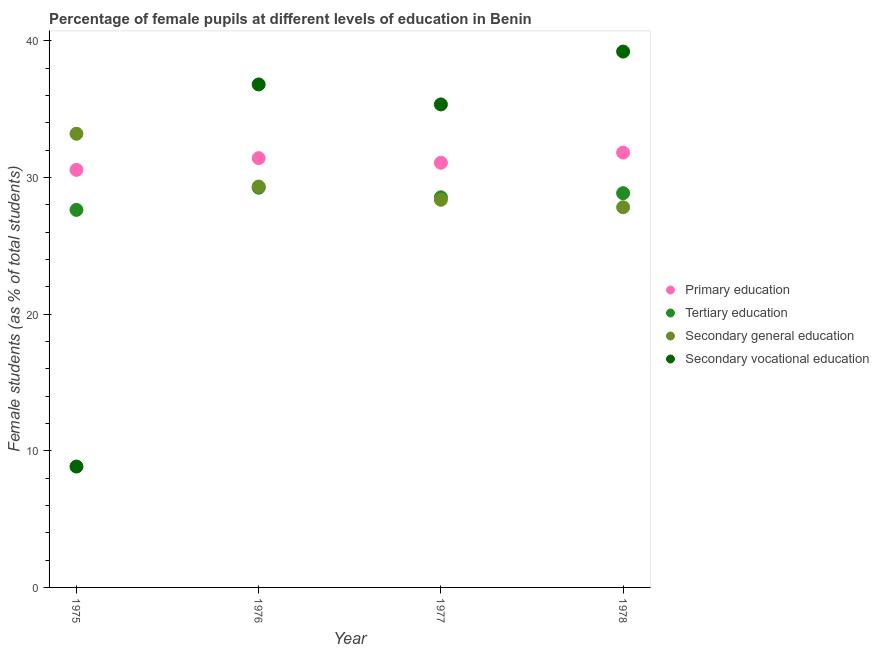Is the number of dotlines equal to the number of legend labels?
Offer a terse response. Yes. What is the percentage of female students in tertiary education in 1975?
Your answer should be very brief. 27.62. Across all years, what is the maximum percentage of female students in tertiary education?
Your answer should be very brief. 29.25. Across all years, what is the minimum percentage of female students in primary education?
Your answer should be compact. 30.55. In which year was the percentage of female students in tertiary education maximum?
Offer a very short reply. 1976. In which year was the percentage of female students in primary education minimum?
Offer a terse response. 1975. What is the total percentage of female students in tertiary education in the graph?
Give a very brief answer. 114.26. What is the difference between the percentage of female students in secondary education in 1975 and that in 1977?
Your answer should be compact. 4.83. What is the difference between the percentage of female students in secondary vocational education in 1975 and the percentage of female students in primary education in 1978?
Provide a short and direct response. -22.97. What is the average percentage of female students in secondary education per year?
Give a very brief answer. 29.68. In the year 1975, what is the difference between the percentage of female students in secondary vocational education and percentage of female students in primary education?
Your response must be concise. -21.71. In how many years, is the percentage of female students in secondary vocational education greater than 6 %?
Your answer should be compact. 4. What is the ratio of the percentage of female students in primary education in 1975 to that in 1978?
Make the answer very short. 0.96. Is the difference between the percentage of female students in secondary vocational education in 1975 and 1976 greater than the difference between the percentage of female students in primary education in 1975 and 1976?
Keep it short and to the point. No. What is the difference between the highest and the second highest percentage of female students in tertiary education?
Your answer should be compact. 0.4. What is the difference between the highest and the lowest percentage of female students in secondary education?
Your response must be concise. 5.38. Is the sum of the percentage of female students in secondary education in 1975 and 1976 greater than the maximum percentage of female students in secondary vocational education across all years?
Offer a very short reply. Yes. Does the percentage of female students in tertiary education monotonically increase over the years?
Your response must be concise. No. Is the percentage of female students in secondary education strictly less than the percentage of female students in primary education over the years?
Make the answer very short. No. How many dotlines are there?
Make the answer very short. 4. Does the graph contain grids?
Your answer should be compact. No. Where does the legend appear in the graph?
Your answer should be very brief. Center right. What is the title of the graph?
Offer a very short reply. Percentage of female pupils at different levels of education in Benin. Does "Social equity" appear as one of the legend labels in the graph?
Your answer should be very brief. No. What is the label or title of the Y-axis?
Ensure brevity in your answer.  Female students (as % of total students). What is the Female students (as % of total students) in Primary education in 1975?
Make the answer very short. 30.55. What is the Female students (as % of total students) in Tertiary education in 1975?
Your answer should be very brief. 27.62. What is the Female students (as % of total students) of Secondary general education in 1975?
Your answer should be very brief. 33.19. What is the Female students (as % of total students) in Secondary vocational education in 1975?
Offer a very short reply. 8.84. What is the Female students (as % of total students) in Primary education in 1976?
Provide a succinct answer. 31.41. What is the Female students (as % of total students) in Tertiary education in 1976?
Your answer should be compact. 29.25. What is the Female students (as % of total students) of Secondary general education in 1976?
Keep it short and to the point. 29.33. What is the Female students (as % of total students) of Secondary vocational education in 1976?
Provide a succinct answer. 36.8. What is the Female students (as % of total students) of Primary education in 1977?
Make the answer very short. 31.07. What is the Female students (as % of total students) of Tertiary education in 1977?
Give a very brief answer. 28.54. What is the Female students (as % of total students) of Secondary general education in 1977?
Keep it short and to the point. 28.36. What is the Female students (as % of total students) in Secondary vocational education in 1977?
Your answer should be very brief. 35.34. What is the Female students (as % of total students) in Primary education in 1978?
Your answer should be very brief. 31.81. What is the Female students (as % of total students) in Tertiary education in 1978?
Keep it short and to the point. 28.84. What is the Female students (as % of total students) in Secondary general education in 1978?
Provide a short and direct response. 27.81. What is the Female students (as % of total students) of Secondary vocational education in 1978?
Provide a succinct answer. 39.21. Across all years, what is the maximum Female students (as % of total students) of Primary education?
Keep it short and to the point. 31.81. Across all years, what is the maximum Female students (as % of total students) of Tertiary education?
Your answer should be very brief. 29.25. Across all years, what is the maximum Female students (as % of total students) of Secondary general education?
Offer a terse response. 33.19. Across all years, what is the maximum Female students (as % of total students) of Secondary vocational education?
Keep it short and to the point. 39.21. Across all years, what is the minimum Female students (as % of total students) in Primary education?
Keep it short and to the point. 30.55. Across all years, what is the minimum Female students (as % of total students) of Tertiary education?
Keep it short and to the point. 27.62. Across all years, what is the minimum Female students (as % of total students) in Secondary general education?
Ensure brevity in your answer.  27.81. Across all years, what is the minimum Female students (as % of total students) in Secondary vocational education?
Offer a very short reply. 8.84. What is the total Female students (as % of total students) of Primary education in the graph?
Offer a very short reply. 124.85. What is the total Female students (as % of total students) of Tertiary education in the graph?
Provide a short and direct response. 114.26. What is the total Female students (as % of total students) of Secondary general education in the graph?
Your answer should be very brief. 118.7. What is the total Female students (as % of total students) in Secondary vocational education in the graph?
Keep it short and to the point. 120.19. What is the difference between the Female students (as % of total students) in Primary education in 1975 and that in 1976?
Your response must be concise. -0.86. What is the difference between the Female students (as % of total students) in Tertiary education in 1975 and that in 1976?
Your answer should be compact. -1.62. What is the difference between the Female students (as % of total students) of Secondary general education in 1975 and that in 1976?
Your response must be concise. 3.86. What is the difference between the Female students (as % of total students) in Secondary vocational education in 1975 and that in 1976?
Offer a terse response. -27.96. What is the difference between the Female students (as % of total students) in Primary education in 1975 and that in 1977?
Make the answer very short. -0.52. What is the difference between the Female students (as % of total students) in Tertiary education in 1975 and that in 1977?
Offer a very short reply. -0.92. What is the difference between the Female students (as % of total students) of Secondary general education in 1975 and that in 1977?
Your answer should be very brief. 4.83. What is the difference between the Female students (as % of total students) of Secondary vocational education in 1975 and that in 1977?
Keep it short and to the point. -26.5. What is the difference between the Female students (as % of total students) of Primary education in 1975 and that in 1978?
Offer a very short reply. -1.26. What is the difference between the Female students (as % of total students) of Tertiary education in 1975 and that in 1978?
Offer a very short reply. -1.22. What is the difference between the Female students (as % of total students) in Secondary general education in 1975 and that in 1978?
Provide a succinct answer. 5.38. What is the difference between the Female students (as % of total students) of Secondary vocational education in 1975 and that in 1978?
Provide a short and direct response. -30.36. What is the difference between the Female students (as % of total students) of Primary education in 1976 and that in 1977?
Provide a succinct answer. 0.34. What is the difference between the Female students (as % of total students) of Tertiary education in 1976 and that in 1977?
Your response must be concise. 0.7. What is the difference between the Female students (as % of total students) of Secondary general education in 1976 and that in 1977?
Provide a short and direct response. 0.97. What is the difference between the Female students (as % of total students) in Secondary vocational education in 1976 and that in 1977?
Offer a very short reply. 1.46. What is the difference between the Female students (as % of total students) of Primary education in 1976 and that in 1978?
Keep it short and to the point. -0.41. What is the difference between the Female students (as % of total students) in Tertiary education in 1976 and that in 1978?
Provide a succinct answer. 0.4. What is the difference between the Female students (as % of total students) of Secondary general education in 1976 and that in 1978?
Ensure brevity in your answer.  1.52. What is the difference between the Female students (as % of total students) of Secondary vocational education in 1976 and that in 1978?
Ensure brevity in your answer.  -2.4. What is the difference between the Female students (as % of total students) of Primary education in 1977 and that in 1978?
Make the answer very short. -0.74. What is the difference between the Female students (as % of total students) of Tertiary education in 1977 and that in 1978?
Offer a terse response. -0.3. What is the difference between the Female students (as % of total students) in Secondary general education in 1977 and that in 1978?
Make the answer very short. 0.55. What is the difference between the Female students (as % of total students) in Secondary vocational education in 1977 and that in 1978?
Your response must be concise. -3.87. What is the difference between the Female students (as % of total students) in Primary education in 1975 and the Female students (as % of total students) in Tertiary education in 1976?
Offer a terse response. 1.31. What is the difference between the Female students (as % of total students) of Primary education in 1975 and the Female students (as % of total students) of Secondary general education in 1976?
Provide a succinct answer. 1.22. What is the difference between the Female students (as % of total students) in Primary education in 1975 and the Female students (as % of total students) in Secondary vocational education in 1976?
Ensure brevity in your answer.  -6.25. What is the difference between the Female students (as % of total students) of Tertiary education in 1975 and the Female students (as % of total students) of Secondary general education in 1976?
Offer a very short reply. -1.71. What is the difference between the Female students (as % of total students) of Tertiary education in 1975 and the Female students (as % of total students) of Secondary vocational education in 1976?
Offer a very short reply. -9.18. What is the difference between the Female students (as % of total students) in Secondary general education in 1975 and the Female students (as % of total students) in Secondary vocational education in 1976?
Make the answer very short. -3.61. What is the difference between the Female students (as % of total students) of Primary education in 1975 and the Female students (as % of total students) of Tertiary education in 1977?
Offer a very short reply. 2.01. What is the difference between the Female students (as % of total students) of Primary education in 1975 and the Female students (as % of total students) of Secondary general education in 1977?
Give a very brief answer. 2.19. What is the difference between the Female students (as % of total students) of Primary education in 1975 and the Female students (as % of total students) of Secondary vocational education in 1977?
Offer a very short reply. -4.79. What is the difference between the Female students (as % of total students) of Tertiary education in 1975 and the Female students (as % of total students) of Secondary general education in 1977?
Ensure brevity in your answer.  -0.74. What is the difference between the Female students (as % of total students) of Tertiary education in 1975 and the Female students (as % of total students) of Secondary vocational education in 1977?
Keep it short and to the point. -7.72. What is the difference between the Female students (as % of total students) of Secondary general education in 1975 and the Female students (as % of total students) of Secondary vocational education in 1977?
Your answer should be compact. -2.15. What is the difference between the Female students (as % of total students) in Primary education in 1975 and the Female students (as % of total students) in Tertiary education in 1978?
Provide a short and direct response. 1.71. What is the difference between the Female students (as % of total students) in Primary education in 1975 and the Female students (as % of total students) in Secondary general education in 1978?
Offer a very short reply. 2.74. What is the difference between the Female students (as % of total students) of Primary education in 1975 and the Female students (as % of total students) of Secondary vocational education in 1978?
Your answer should be compact. -8.65. What is the difference between the Female students (as % of total students) of Tertiary education in 1975 and the Female students (as % of total students) of Secondary general education in 1978?
Keep it short and to the point. -0.19. What is the difference between the Female students (as % of total students) in Tertiary education in 1975 and the Female students (as % of total students) in Secondary vocational education in 1978?
Your answer should be compact. -11.58. What is the difference between the Female students (as % of total students) of Secondary general education in 1975 and the Female students (as % of total students) of Secondary vocational education in 1978?
Provide a succinct answer. -6.01. What is the difference between the Female students (as % of total students) in Primary education in 1976 and the Female students (as % of total students) in Tertiary education in 1977?
Ensure brevity in your answer.  2.87. What is the difference between the Female students (as % of total students) in Primary education in 1976 and the Female students (as % of total students) in Secondary general education in 1977?
Provide a short and direct response. 3.04. What is the difference between the Female students (as % of total students) in Primary education in 1976 and the Female students (as % of total students) in Secondary vocational education in 1977?
Your response must be concise. -3.93. What is the difference between the Female students (as % of total students) of Tertiary education in 1976 and the Female students (as % of total students) of Secondary general education in 1977?
Your answer should be very brief. 0.88. What is the difference between the Female students (as % of total students) of Tertiary education in 1976 and the Female students (as % of total students) of Secondary vocational education in 1977?
Offer a very short reply. -6.09. What is the difference between the Female students (as % of total students) of Secondary general education in 1976 and the Female students (as % of total students) of Secondary vocational education in 1977?
Give a very brief answer. -6.01. What is the difference between the Female students (as % of total students) of Primary education in 1976 and the Female students (as % of total students) of Tertiary education in 1978?
Offer a very short reply. 2.56. What is the difference between the Female students (as % of total students) of Primary education in 1976 and the Female students (as % of total students) of Secondary general education in 1978?
Your answer should be compact. 3.59. What is the difference between the Female students (as % of total students) in Primary education in 1976 and the Female students (as % of total students) in Secondary vocational education in 1978?
Keep it short and to the point. -7.8. What is the difference between the Female students (as % of total students) in Tertiary education in 1976 and the Female students (as % of total students) in Secondary general education in 1978?
Your response must be concise. 1.43. What is the difference between the Female students (as % of total students) in Tertiary education in 1976 and the Female students (as % of total students) in Secondary vocational education in 1978?
Your answer should be compact. -9.96. What is the difference between the Female students (as % of total students) of Secondary general education in 1976 and the Female students (as % of total students) of Secondary vocational education in 1978?
Give a very brief answer. -9.87. What is the difference between the Female students (as % of total students) in Primary education in 1977 and the Female students (as % of total students) in Tertiary education in 1978?
Offer a terse response. 2.23. What is the difference between the Female students (as % of total students) of Primary education in 1977 and the Female students (as % of total students) of Secondary general education in 1978?
Your answer should be compact. 3.26. What is the difference between the Female students (as % of total students) of Primary education in 1977 and the Female students (as % of total students) of Secondary vocational education in 1978?
Make the answer very short. -8.13. What is the difference between the Female students (as % of total students) in Tertiary education in 1977 and the Female students (as % of total students) in Secondary general education in 1978?
Give a very brief answer. 0.73. What is the difference between the Female students (as % of total students) of Tertiary education in 1977 and the Female students (as % of total students) of Secondary vocational education in 1978?
Offer a terse response. -10.66. What is the difference between the Female students (as % of total students) of Secondary general education in 1977 and the Female students (as % of total students) of Secondary vocational education in 1978?
Provide a succinct answer. -10.84. What is the average Female students (as % of total students) in Primary education per year?
Your response must be concise. 31.21. What is the average Female students (as % of total students) of Tertiary education per year?
Ensure brevity in your answer.  28.56. What is the average Female students (as % of total students) of Secondary general education per year?
Keep it short and to the point. 29.68. What is the average Female students (as % of total students) of Secondary vocational education per year?
Keep it short and to the point. 30.05. In the year 1975, what is the difference between the Female students (as % of total students) of Primary education and Female students (as % of total students) of Tertiary education?
Offer a terse response. 2.93. In the year 1975, what is the difference between the Female students (as % of total students) in Primary education and Female students (as % of total students) in Secondary general education?
Give a very brief answer. -2.64. In the year 1975, what is the difference between the Female students (as % of total students) in Primary education and Female students (as % of total students) in Secondary vocational education?
Make the answer very short. 21.71. In the year 1975, what is the difference between the Female students (as % of total students) in Tertiary education and Female students (as % of total students) in Secondary general education?
Offer a terse response. -5.57. In the year 1975, what is the difference between the Female students (as % of total students) in Tertiary education and Female students (as % of total students) in Secondary vocational education?
Offer a very short reply. 18.78. In the year 1975, what is the difference between the Female students (as % of total students) of Secondary general education and Female students (as % of total students) of Secondary vocational education?
Your response must be concise. 24.35. In the year 1976, what is the difference between the Female students (as % of total students) in Primary education and Female students (as % of total students) in Tertiary education?
Offer a terse response. 2.16. In the year 1976, what is the difference between the Female students (as % of total students) in Primary education and Female students (as % of total students) in Secondary general education?
Keep it short and to the point. 2.08. In the year 1976, what is the difference between the Female students (as % of total students) of Primary education and Female students (as % of total students) of Secondary vocational education?
Your answer should be very brief. -5.39. In the year 1976, what is the difference between the Female students (as % of total students) of Tertiary education and Female students (as % of total students) of Secondary general education?
Provide a short and direct response. -0.08. In the year 1976, what is the difference between the Female students (as % of total students) of Tertiary education and Female students (as % of total students) of Secondary vocational education?
Provide a succinct answer. -7.55. In the year 1976, what is the difference between the Female students (as % of total students) in Secondary general education and Female students (as % of total students) in Secondary vocational education?
Your answer should be compact. -7.47. In the year 1977, what is the difference between the Female students (as % of total students) of Primary education and Female students (as % of total students) of Tertiary education?
Provide a short and direct response. 2.53. In the year 1977, what is the difference between the Female students (as % of total students) in Primary education and Female students (as % of total students) in Secondary general education?
Offer a terse response. 2.71. In the year 1977, what is the difference between the Female students (as % of total students) in Primary education and Female students (as % of total students) in Secondary vocational education?
Offer a terse response. -4.27. In the year 1977, what is the difference between the Female students (as % of total students) of Tertiary education and Female students (as % of total students) of Secondary general education?
Make the answer very short. 0.18. In the year 1977, what is the difference between the Female students (as % of total students) in Tertiary education and Female students (as % of total students) in Secondary vocational education?
Ensure brevity in your answer.  -6.8. In the year 1977, what is the difference between the Female students (as % of total students) of Secondary general education and Female students (as % of total students) of Secondary vocational education?
Your answer should be very brief. -6.98. In the year 1978, what is the difference between the Female students (as % of total students) in Primary education and Female students (as % of total students) in Tertiary education?
Provide a short and direct response. 2.97. In the year 1978, what is the difference between the Female students (as % of total students) of Primary education and Female students (as % of total students) of Secondary general education?
Provide a succinct answer. 4. In the year 1978, what is the difference between the Female students (as % of total students) in Primary education and Female students (as % of total students) in Secondary vocational education?
Your answer should be compact. -7.39. In the year 1978, what is the difference between the Female students (as % of total students) of Tertiary education and Female students (as % of total students) of Secondary general education?
Give a very brief answer. 1.03. In the year 1978, what is the difference between the Female students (as % of total students) in Tertiary education and Female students (as % of total students) in Secondary vocational education?
Offer a terse response. -10.36. In the year 1978, what is the difference between the Female students (as % of total students) in Secondary general education and Female students (as % of total students) in Secondary vocational education?
Give a very brief answer. -11.39. What is the ratio of the Female students (as % of total students) of Primary education in 1975 to that in 1976?
Your response must be concise. 0.97. What is the ratio of the Female students (as % of total students) of Tertiary education in 1975 to that in 1976?
Provide a short and direct response. 0.94. What is the ratio of the Female students (as % of total students) in Secondary general education in 1975 to that in 1976?
Make the answer very short. 1.13. What is the ratio of the Female students (as % of total students) of Secondary vocational education in 1975 to that in 1976?
Your response must be concise. 0.24. What is the ratio of the Female students (as % of total students) in Primary education in 1975 to that in 1977?
Give a very brief answer. 0.98. What is the ratio of the Female students (as % of total students) in Tertiary education in 1975 to that in 1977?
Make the answer very short. 0.97. What is the ratio of the Female students (as % of total students) of Secondary general education in 1975 to that in 1977?
Make the answer very short. 1.17. What is the ratio of the Female students (as % of total students) of Secondary vocational education in 1975 to that in 1977?
Your answer should be very brief. 0.25. What is the ratio of the Female students (as % of total students) of Primary education in 1975 to that in 1978?
Give a very brief answer. 0.96. What is the ratio of the Female students (as % of total students) in Tertiary education in 1975 to that in 1978?
Offer a terse response. 0.96. What is the ratio of the Female students (as % of total students) of Secondary general education in 1975 to that in 1978?
Offer a terse response. 1.19. What is the ratio of the Female students (as % of total students) of Secondary vocational education in 1975 to that in 1978?
Your answer should be compact. 0.23. What is the ratio of the Female students (as % of total students) of Primary education in 1976 to that in 1977?
Your answer should be compact. 1.01. What is the ratio of the Female students (as % of total students) in Tertiary education in 1976 to that in 1977?
Offer a terse response. 1.02. What is the ratio of the Female students (as % of total students) in Secondary general education in 1976 to that in 1977?
Make the answer very short. 1.03. What is the ratio of the Female students (as % of total students) of Secondary vocational education in 1976 to that in 1977?
Provide a succinct answer. 1.04. What is the ratio of the Female students (as % of total students) of Primary education in 1976 to that in 1978?
Your answer should be compact. 0.99. What is the ratio of the Female students (as % of total students) of Tertiary education in 1976 to that in 1978?
Your answer should be compact. 1.01. What is the ratio of the Female students (as % of total students) of Secondary general education in 1976 to that in 1978?
Make the answer very short. 1.05. What is the ratio of the Female students (as % of total students) of Secondary vocational education in 1976 to that in 1978?
Your answer should be compact. 0.94. What is the ratio of the Female students (as % of total students) in Primary education in 1977 to that in 1978?
Your answer should be very brief. 0.98. What is the ratio of the Female students (as % of total students) in Secondary general education in 1977 to that in 1978?
Keep it short and to the point. 1.02. What is the ratio of the Female students (as % of total students) of Secondary vocational education in 1977 to that in 1978?
Your answer should be compact. 0.9. What is the difference between the highest and the second highest Female students (as % of total students) in Primary education?
Ensure brevity in your answer.  0.41. What is the difference between the highest and the second highest Female students (as % of total students) of Tertiary education?
Provide a short and direct response. 0.4. What is the difference between the highest and the second highest Female students (as % of total students) in Secondary general education?
Your response must be concise. 3.86. What is the difference between the highest and the second highest Female students (as % of total students) in Secondary vocational education?
Your answer should be compact. 2.4. What is the difference between the highest and the lowest Female students (as % of total students) in Primary education?
Your response must be concise. 1.26. What is the difference between the highest and the lowest Female students (as % of total students) in Tertiary education?
Your response must be concise. 1.62. What is the difference between the highest and the lowest Female students (as % of total students) of Secondary general education?
Your answer should be very brief. 5.38. What is the difference between the highest and the lowest Female students (as % of total students) of Secondary vocational education?
Offer a very short reply. 30.36. 